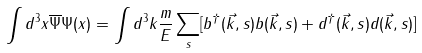Convert formula to latex. <formula><loc_0><loc_0><loc_500><loc_500>\int d ^ { 3 } x \overline { \Psi } \Psi ( x ) = \int d ^ { 3 } k \frac { m } { E } \sum _ { s } [ b ^ { \dagger } ( \vec { k } , s ) b ( \vec { k } , s ) + d ^ { \dagger } ( \vec { k } , s ) d ( \vec { k } , s ) ]</formula> 